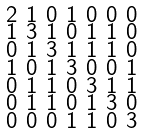Convert formula to latex. <formula><loc_0><loc_0><loc_500><loc_500>\begin{smallmatrix} 2 & 1 & 0 & 1 & 0 & 0 & 0 \\ 1 & 3 & 1 & 0 & 1 & 1 & 0 \\ 0 & 1 & 3 & 1 & 1 & 1 & 0 \\ 1 & 0 & 1 & 3 & 0 & 0 & 1 \\ 0 & 1 & 1 & 0 & 3 & 1 & 1 \\ 0 & 1 & 1 & 0 & 1 & 3 & 0 \\ 0 & 0 & 0 & 1 & 1 & 0 & 3 \end{smallmatrix}</formula> 